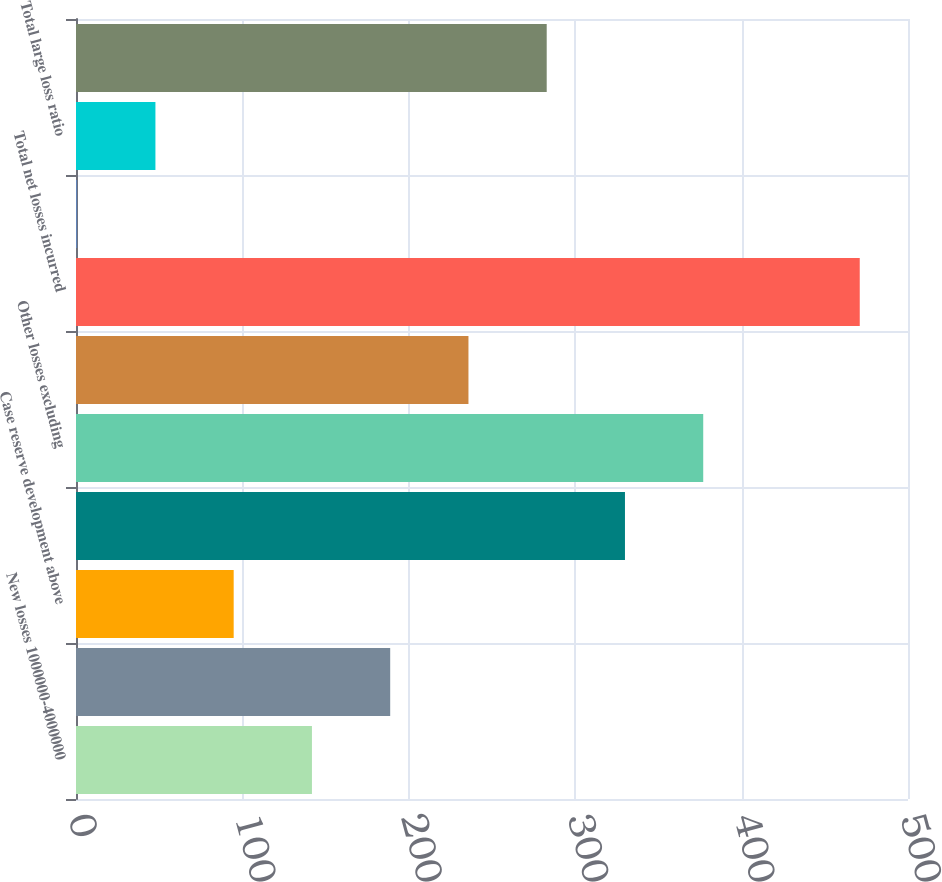<chart> <loc_0><loc_0><loc_500><loc_500><bar_chart><fcel>New losses 1000000-4000000<fcel>New losses 250000-1000000<fcel>Case reserve development above<fcel>Total large losses incurred<fcel>Other losses excluding<fcel>Catastrophe losses<fcel>Total net losses incurred<fcel>New losses greater than<fcel>Total large loss ratio<fcel>Total net loss ratio<nl><fcel>141.79<fcel>188.82<fcel>94.76<fcel>329.91<fcel>376.94<fcel>235.85<fcel>471<fcel>0.7<fcel>47.73<fcel>282.88<nl></chart> 